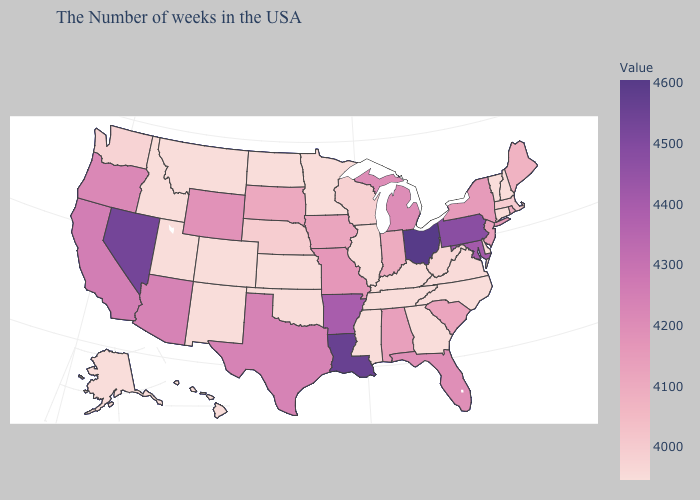Does the map have missing data?
Write a very short answer. No. Which states have the highest value in the USA?
Quick response, please. Ohio. Among the states that border Montana , which have the lowest value?
Keep it brief. North Dakota, Idaho. Among the states that border Ohio , which have the lowest value?
Be succinct. Kentucky. Does New Mexico have the lowest value in the USA?
Keep it brief. Yes. Among the states that border North Dakota , which have the highest value?
Be succinct. South Dakota. Does the map have missing data?
Short answer required. No. Does the map have missing data?
Give a very brief answer. No. Among the states that border Pennsylvania , which have the highest value?
Concise answer only. Ohio. 